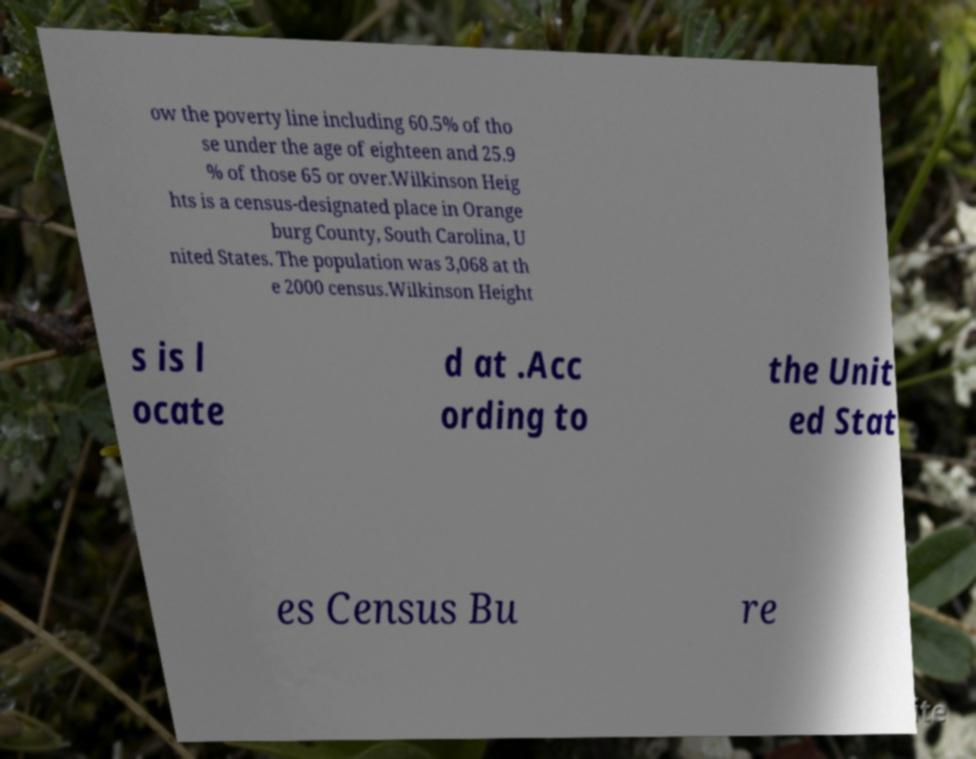Could you assist in decoding the text presented in this image and type it out clearly? ow the poverty line including 60.5% of tho se under the age of eighteen and 25.9 % of those 65 or over.Wilkinson Heig hts is a census-designated place in Orange burg County, South Carolina, U nited States. The population was 3,068 at th e 2000 census.Wilkinson Height s is l ocate d at .Acc ording to the Unit ed Stat es Census Bu re 